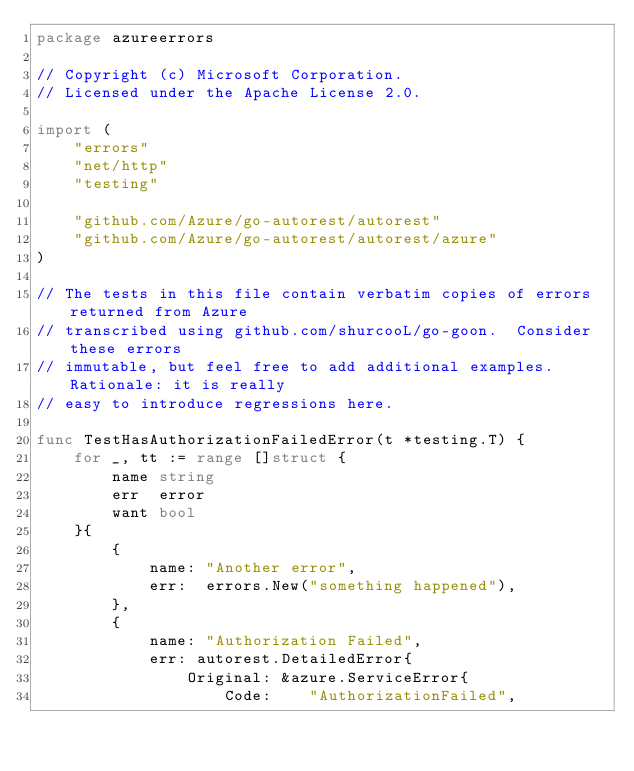Convert code to text. <code><loc_0><loc_0><loc_500><loc_500><_Go_>package azureerrors

// Copyright (c) Microsoft Corporation.
// Licensed under the Apache License 2.0.

import (
	"errors"
	"net/http"
	"testing"

	"github.com/Azure/go-autorest/autorest"
	"github.com/Azure/go-autorest/autorest/azure"
)

// The tests in this file contain verbatim copies of errors returned from Azure
// transcribed using github.com/shurcooL/go-goon.  Consider these errors
// immutable, but feel free to add additional examples.  Rationale: it is really
// easy to introduce regressions here.

func TestHasAuthorizationFailedError(t *testing.T) {
	for _, tt := range []struct {
		name string
		err  error
		want bool
	}{
		{
			name: "Another error",
			err:  errors.New("something happened"),
		},
		{
			name: "Authorization Failed",
			err: autorest.DetailedError{
				Original: &azure.ServiceError{
					Code:    "AuthorizationFailed",</code> 